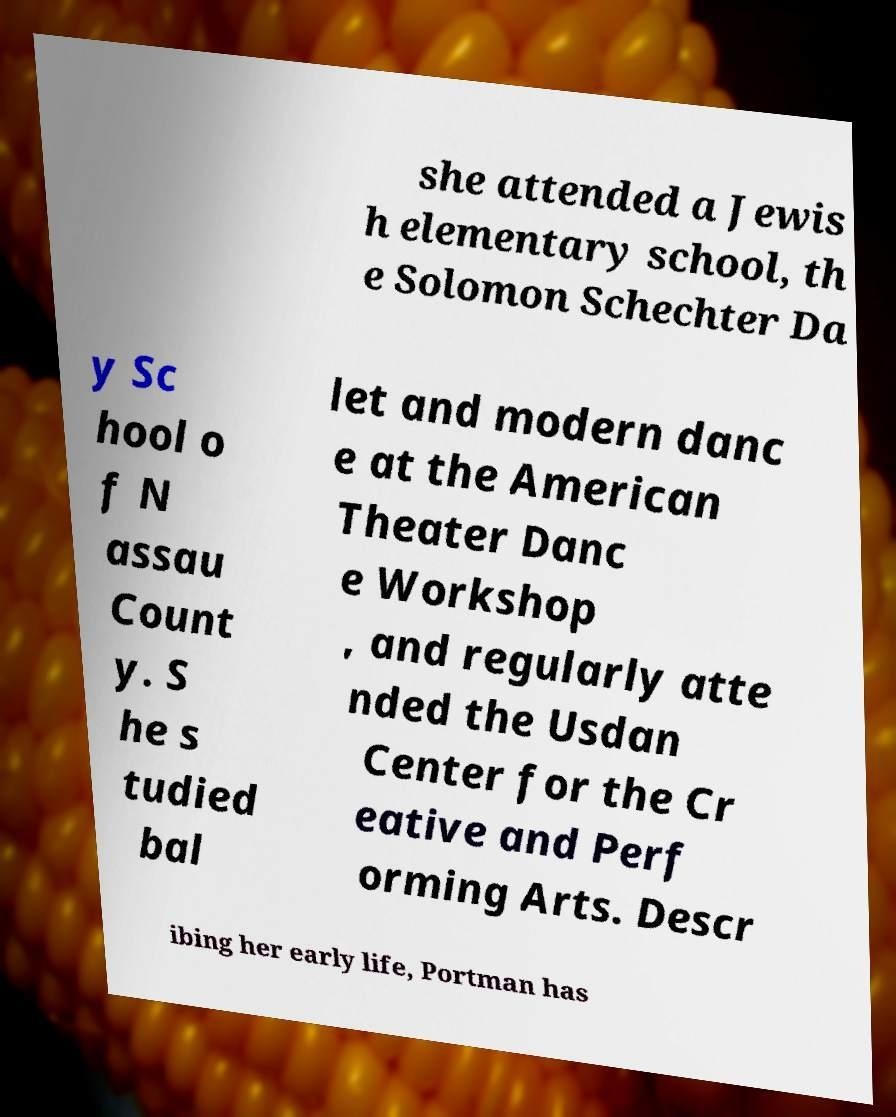Could you assist in decoding the text presented in this image and type it out clearly? she attended a Jewis h elementary school, th e Solomon Schechter Da y Sc hool o f N assau Count y. S he s tudied bal let and modern danc e at the American Theater Danc e Workshop , and regularly atte nded the Usdan Center for the Cr eative and Perf orming Arts. Descr ibing her early life, Portman has 